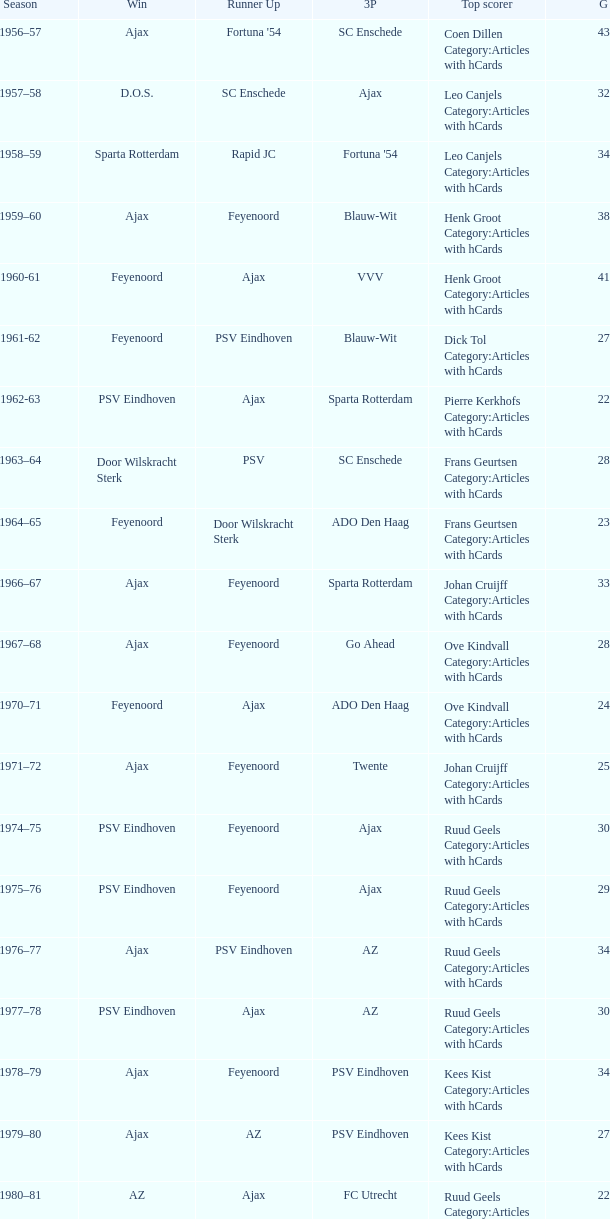When az is the runner up nad feyenoord came in third place how many overall winners are there? 1.0. 